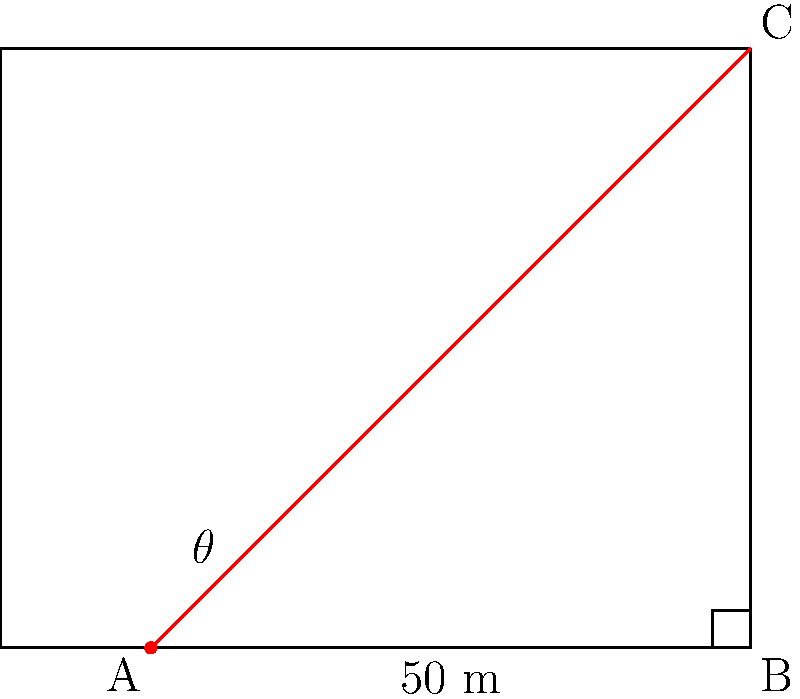At a NASCAR race, you're trying to calculate the height of a grandstand. You're standing 50 meters away from the base of the grandstand, and the angle of elevation to the top of the grandstand is 38°. Using similar triangles and tangent ratios, what is the height of the grandstand to the nearest meter? Let's approach this step-by-step:

1) First, let's identify what we know:
   - The distance from you to the base of the grandstand (adjacent side) is 50 meters.
   - The angle of elevation ($\theta$) is 38°.

2) We need to find the height of the grandstand, which is the opposite side in our right triangle.

3) In a right triangle, the tangent of an angle is the ratio of the opposite side to the adjacent side:

   $\tan \theta = \frac{\text{opposite}}{\text{adjacent}}$

4) We can rearrange this to solve for the opposite side (height):

   $\text{height} = \text{adjacent} \times \tan \theta$

5) Now, let's plug in our known values:

   $\text{height} = 50 \times \tan 38°$

6) Using a calculator (or trigonometric tables):

   $\tan 38° \approx 0.7813$

7) So, our calculation becomes:

   $\text{height} = 50 \times 0.7813 = 39.065$ meters

8) Rounding to the nearest meter:

   $\text{height} \approx 39$ meters

Therefore, the height of the grandstand is approximately 39 meters.
Answer: 39 meters 